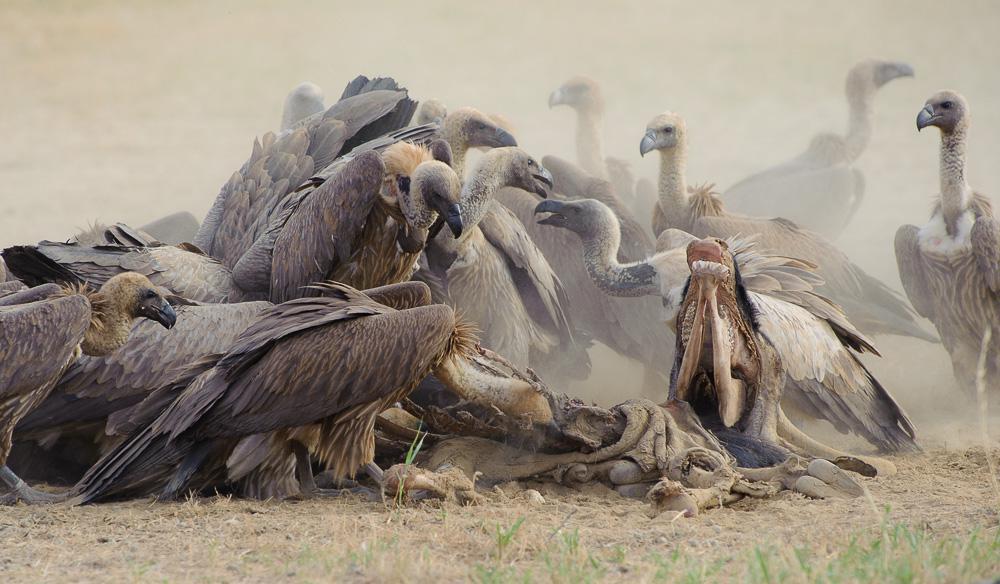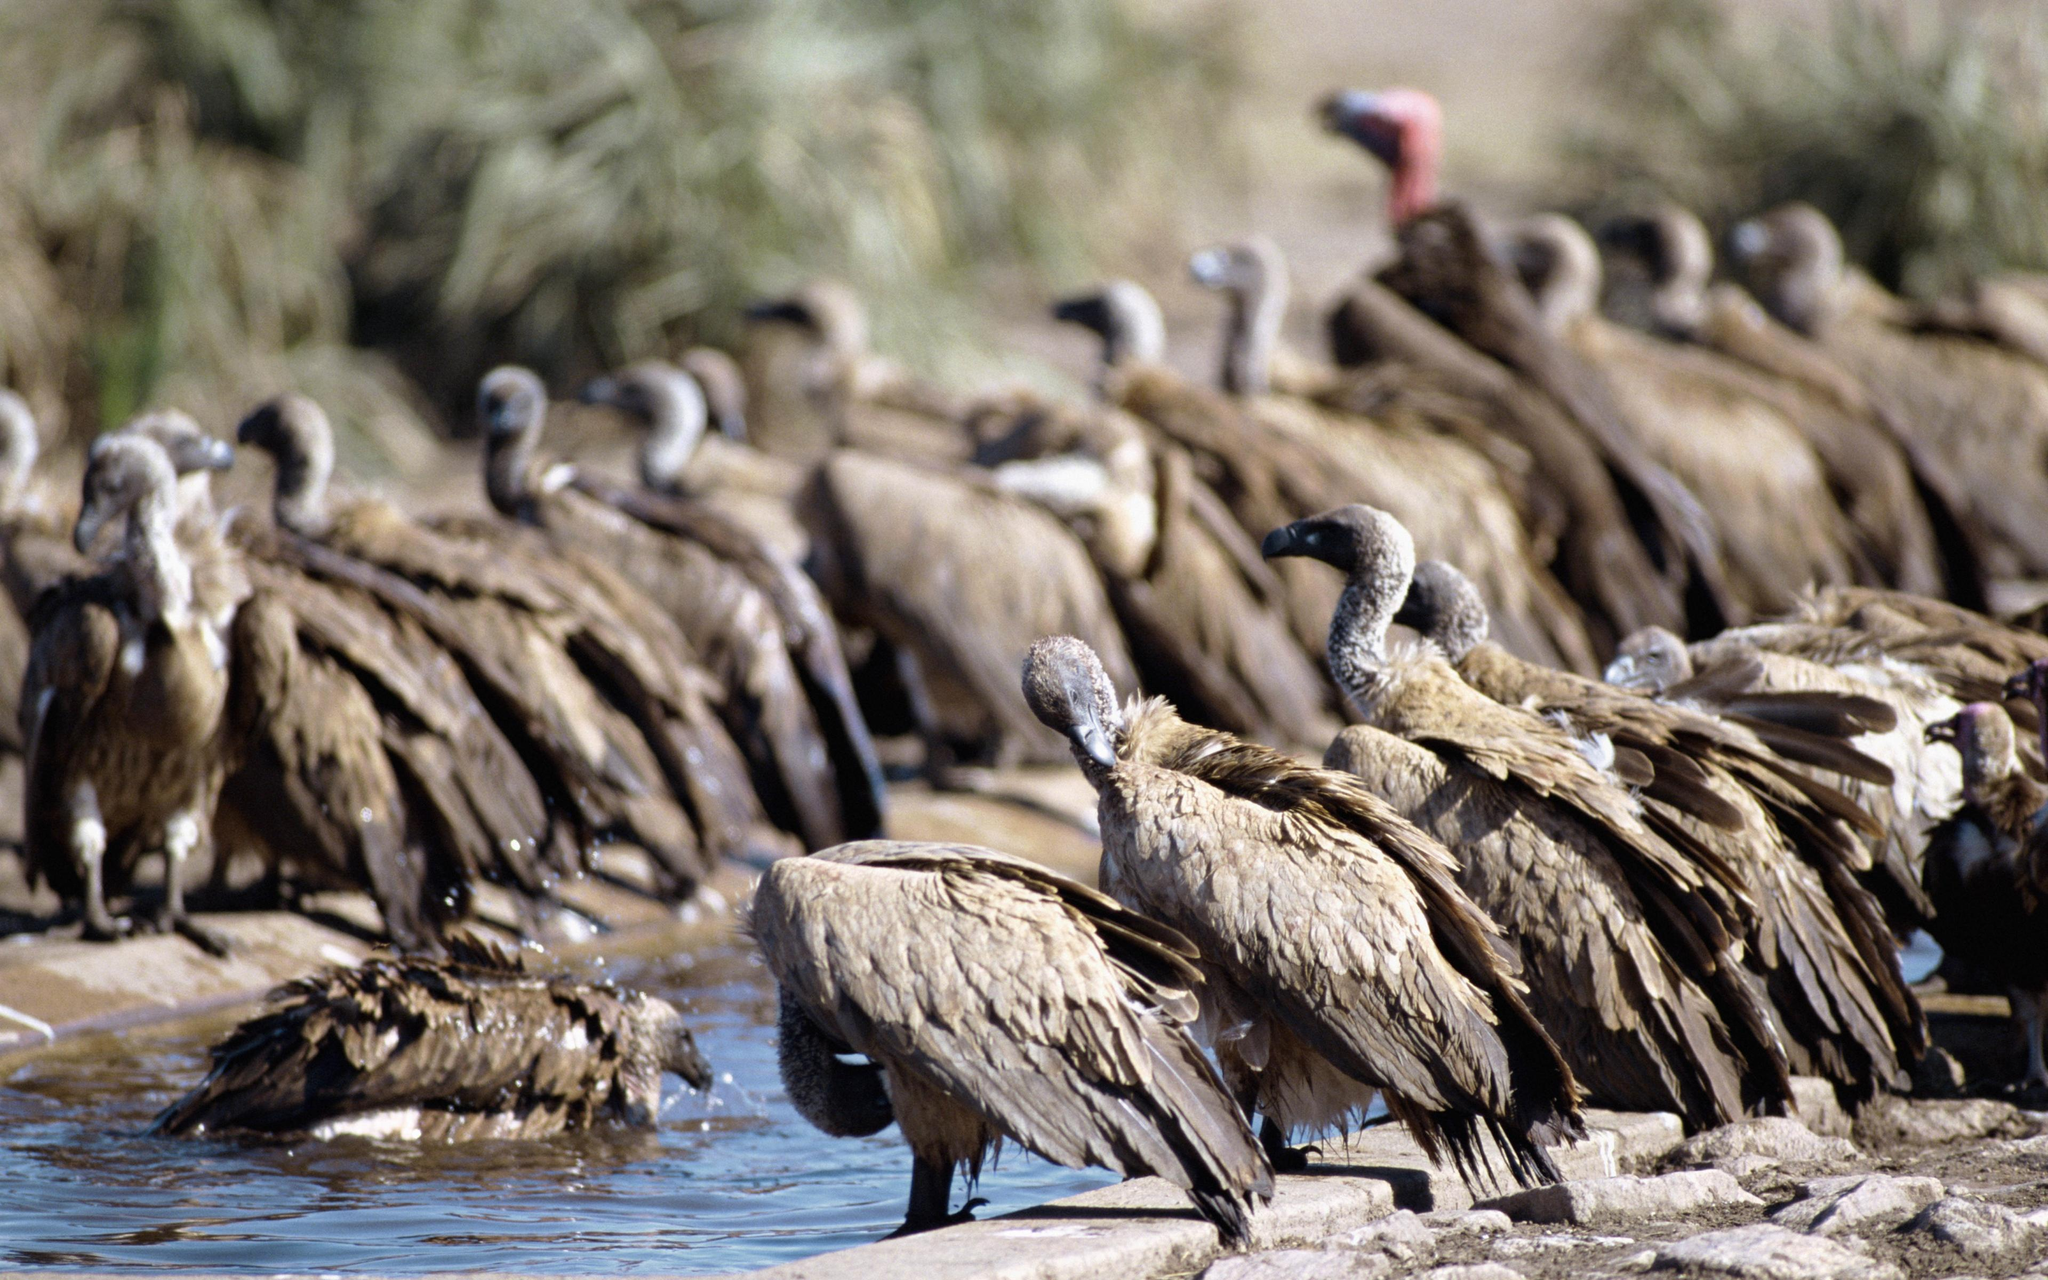The first image is the image on the left, the second image is the image on the right. For the images shown, is this caption "there is water in the image on the right" true? Answer yes or no. Yes. The first image is the image on the left, the second image is the image on the right. Analyze the images presented: Is the assertion "A body of water is visible in one of the images." valid? Answer yes or no. Yes. 